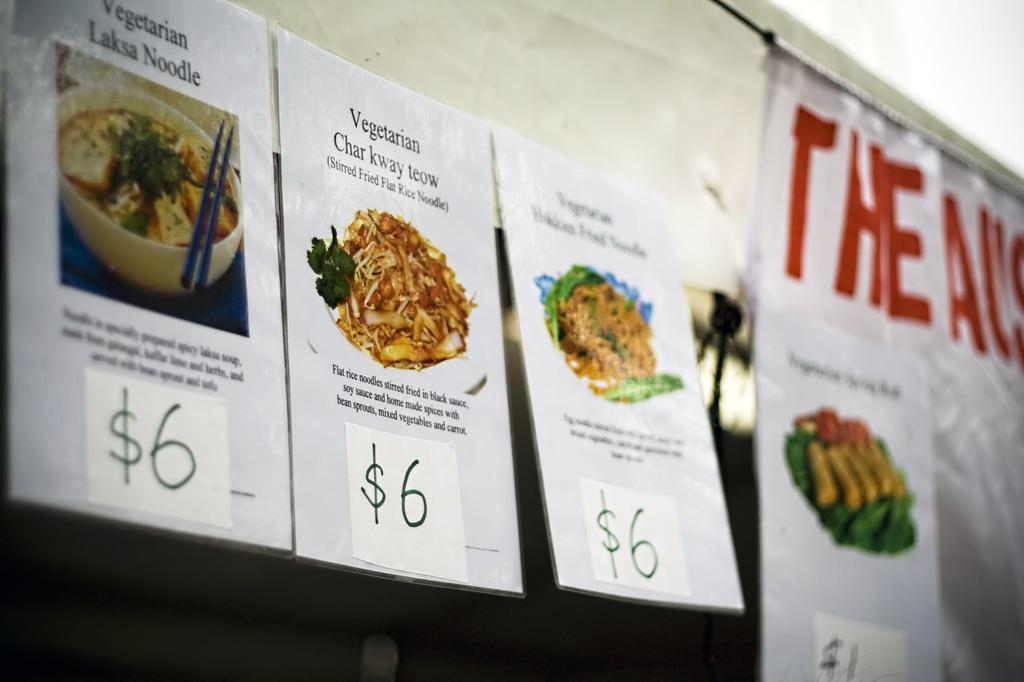What is depicted on the paper in the image? There is food printed on a paper in the image. How is the paper positioned in the image? The paper is hanging on the top. What else can be seen beside the paper in the image? There is a white banner beside the paper. How many teeth can be seen in the image? There are no teeth visible in the image. What type of air is present in the image? There is no specific type of air mentioned or depicted in the image. 